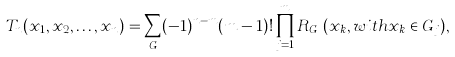Convert formula to latex. <formula><loc_0><loc_0><loc_500><loc_500>T _ { n } ( x _ { 1 } , x _ { 2 } , \dots , x _ { n } ) = \sum _ { G } ( - 1 ) ^ { n - m } ( m - 1 ) ! \prod _ { j = 1 } ^ { m } R _ { G _ { j } } ( x _ { k } , w i t h x _ { k } \in G _ { j } ) ,</formula> 